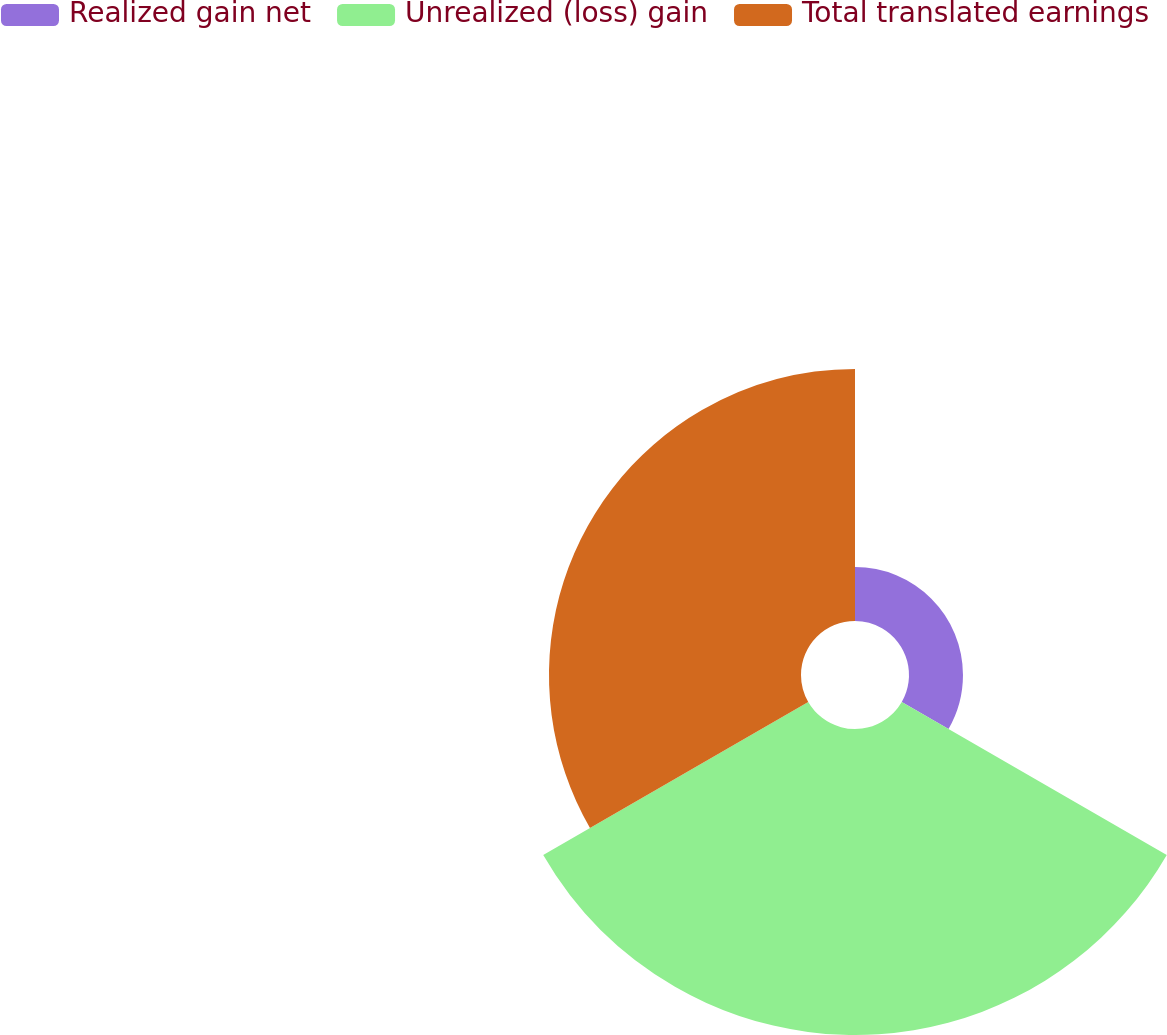<chart> <loc_0><loc_0><loc_500><loc_500><pie_chart><fcel>Realized gain net<fcel>Unrealized (loss) gain<fcel>Total translated earnings<nl><fcel>8.82%<fcel>50.0%<fcel>41.18%<nl></chart> 